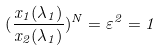<formula> <loc_0><loc_0><loc_500><loc_500>( \frac { x _ { 1 } ( \lambda _ { 1 } ) } { x _ { 2 } ( \lambda _ { 1 } ) } ) ^ { N } = \varepsilon ^ { 2 } = 1</formula> 